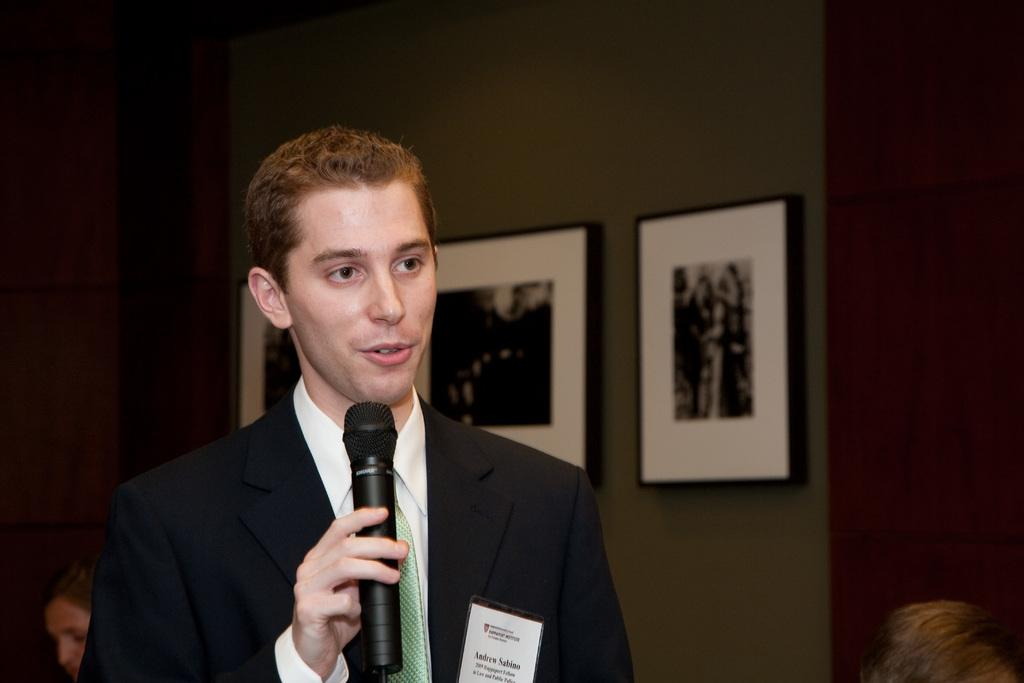What is the man in the room doing? The man is standing in the room and speaking. What is the man holding in the image? The man is holding a microphone. What can be seen on the wall behind the man? There are photo frames on the wall behind the man. How many ladybugs are crawling on the microphone in the image? There are no ladybugs present in the image; the man is holding a microphone while speaking. What type of tomatoes can be seen growing in the photo frames on the wall? There are no tomatoes visible in the image; the photo frames on the wall contain pictures or artwork. 